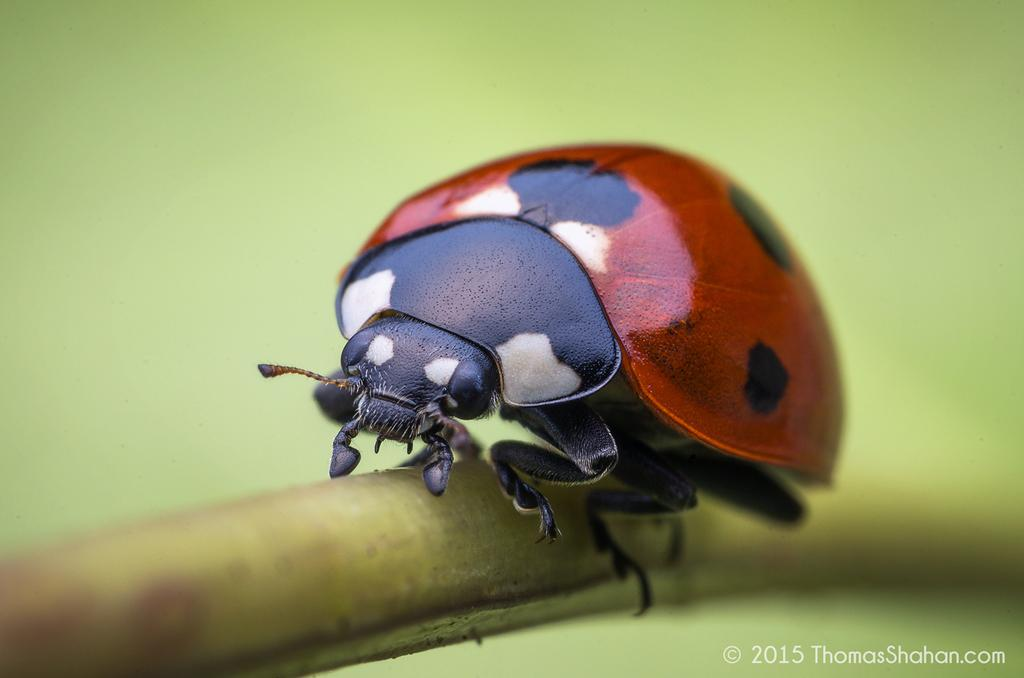What type of creature can be seen in the image? There is an insect in the image. Where is the insect located in the image? The insect is on an object. What can be observed about the background of the image? The background of the image is blurred. Is there any text present in the image? Yes, there is some text in the bottom right corner of the image. What type of fan is visible in the image? There is no fan present in the image; it features an insect on an object with a blurred background and some text in the bottom right corner. 